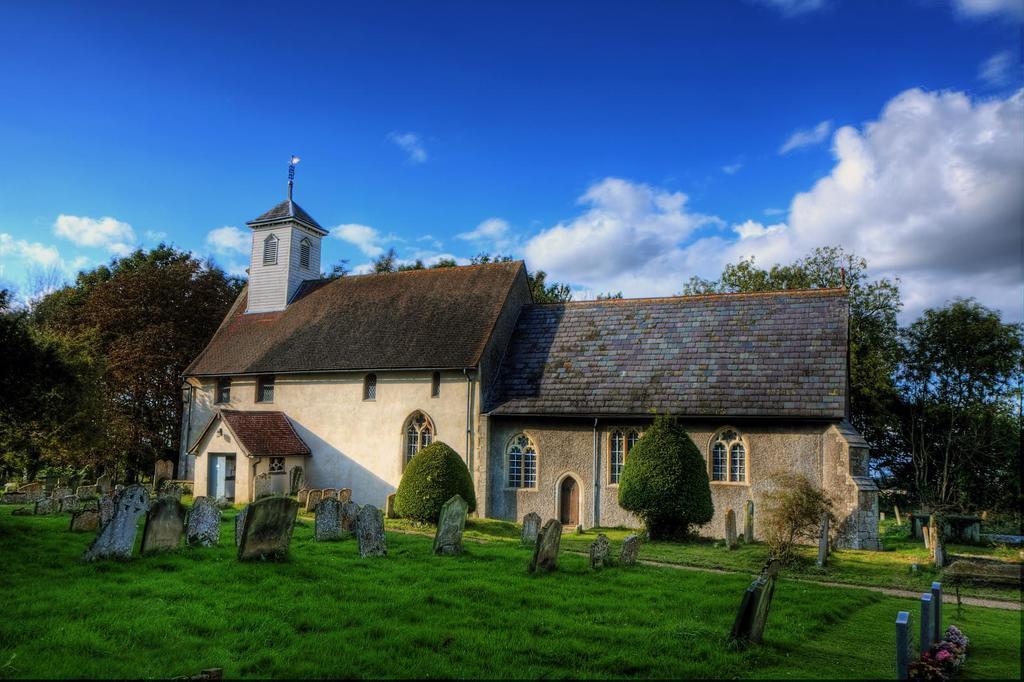How would you summarize this image in a sentence or two? In this image I can see a building in cream and brown color. Background I can see few trees in green color and sky in blue and white color. 